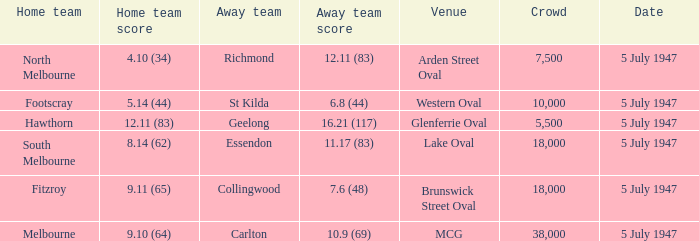What home team played an away team with a score of 6.8 (44)? Footscray. 